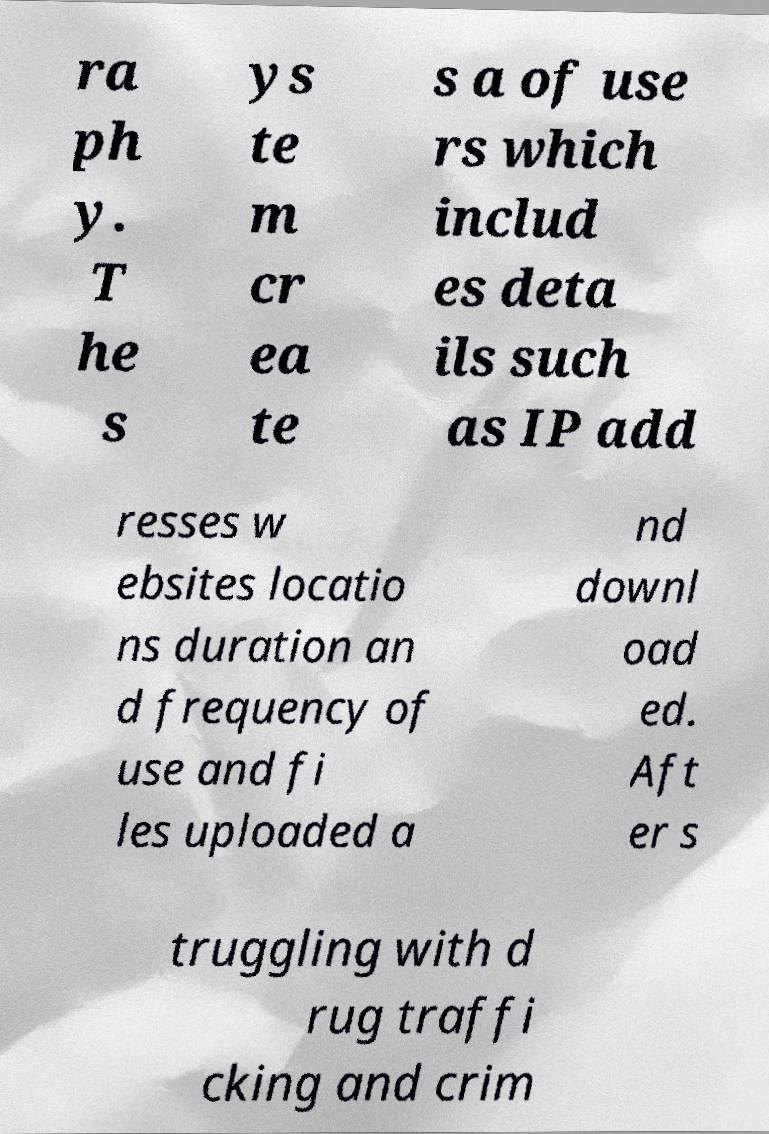Could you assist in decoding the text presented in this image and type it out clearly? ra ph y. T he s ys te m cr ea te s a of use rs which includ es deta ils such as IP add resses w ebsites locatio ns duration an d frequency of use and fi les uploaded a nd downl oad ed. Aft er s truggling with d rug traffi cking and crim 